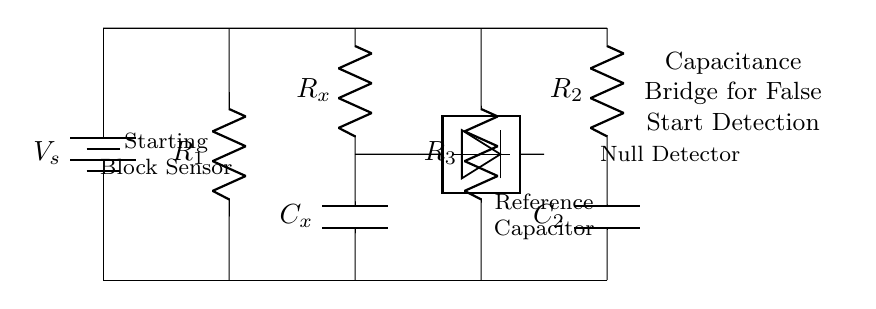What is the main purpose of this circuit? The main purpose of this circuit is to detect false starts in swimming events using a capacitance bridge method. It works by measuring changes in capacitance when a swimmer leaves the starting block.
Answer: Detect false starts What type of sensor is used in this circuit? The circuit uses a starting block sensor to detect the presence or absence of a swimmer at the start. This sensor is critical for assessing if there has been a false start.
Answer: Starting block sensor What component is used as the reference capacitor? In the circuit, the reference capacitor is labeled as C2. It is used as a standard for comparison against the unknown capacitance to identify changes indicating a false start.
Answer: C2 How many resistors are present in this circuit? There are three resistors in the circuit, labeled as R1, R2, and R3. They are essential for controlling the current and voltage levels within the circuit.
Answer: Three resistors What is the significance of the null detector in this circuit? The null detector measures the balance of the bridge circuit. If the voltage level is equal on both sides of the detector, it indicates no false start. If one side has a higher voltage, it shows that the swimmer has moved too soon.
Answer: Balance detection What happens to the output if a false start is detected? If a false start is detected, the output from the null detector will show an imbalance due to the change in capacitance caused when the swimmer breaks the starting block, triggering an alert.
Answer: Imbalance alert Which component can change in value to indicate a swimmer's displacement? The component that changes value to indicate a swimmer's displacement is the unknown capacitor, labeled as Cx. This capacitor's capacitance will vary based on the swimmer's movement.
Answer: Cx 